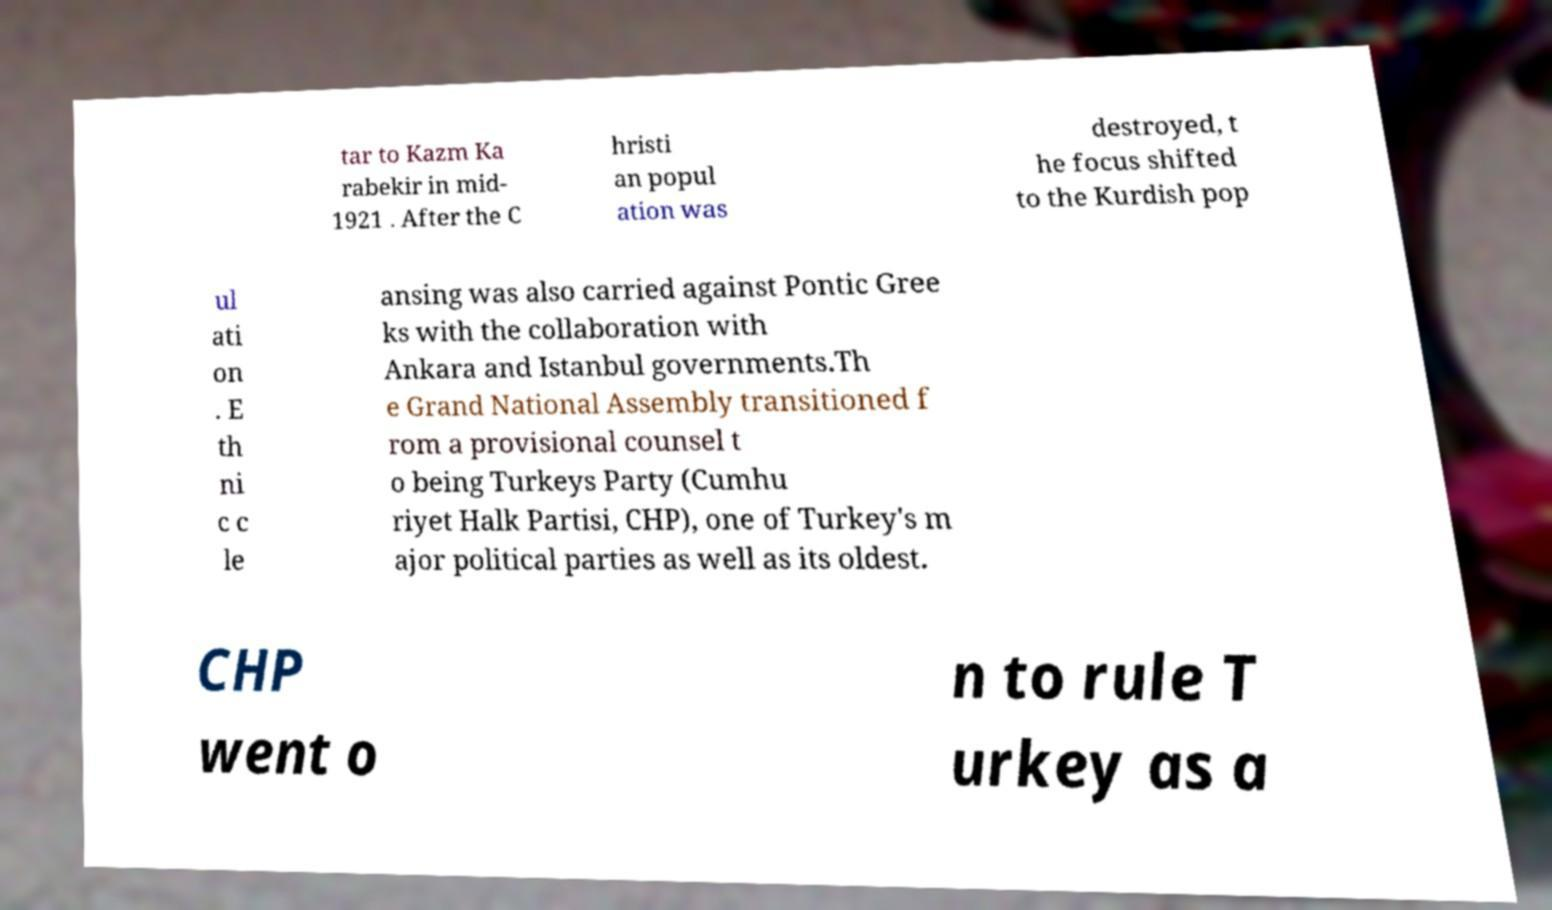There's text embedded in this image that I need extracted. Can you transcribe it verbatim? tar to Kazm Ka rabekir in mid- 1921 . After the C hristi an popul ation was destroyed, t he focus shifted to the Kurdish pop ul ati on . E th ni c c le ansing was also carried against Pontic Gree ks with the collaboration with Ankara and Istanbul governments.Th e Grand National Assembly transitioned f rom a provisional counsel t o being Turkeys Party (Cumhu riyet Halk Partisi, CHP), one of Turkey's m ajor political parties as well as its oldest. CHP went o n to rule T urkey as a 